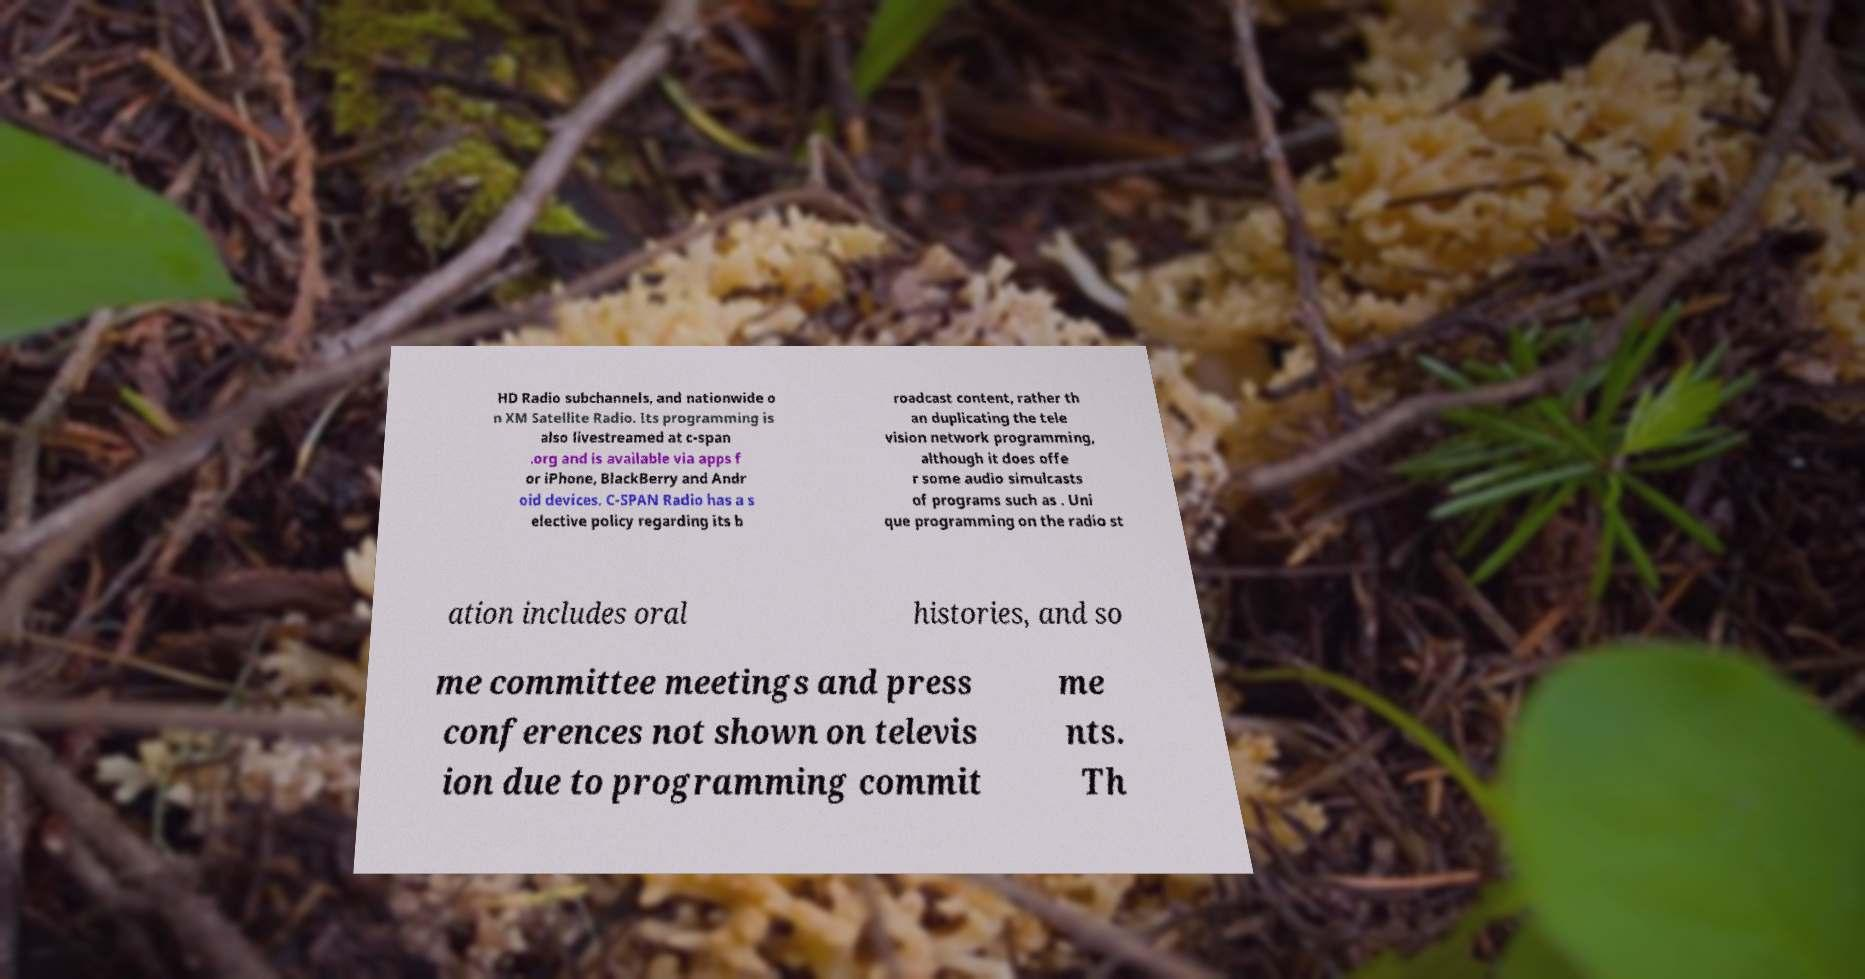Could you assist in decoding the text presented in this image and type it out clearly? HD Radio subchannels, and nationwide o n XM Satellite Radio. Its programming is also livestreamed at c-span .org and is available via apps f or iPhone, BlackBerry and Andr oid devices. C-SPAN Radio has a s elective policy regarding its b roadcast content, rather th an duplicating the tele vision network programming, although it does offe r some audio simulcasts of programs such as . Uni que programming on the radio st ation includes oral histories, and so me committee meetings and press conferences not shown on televis ion due to programming commit me nts. Th 